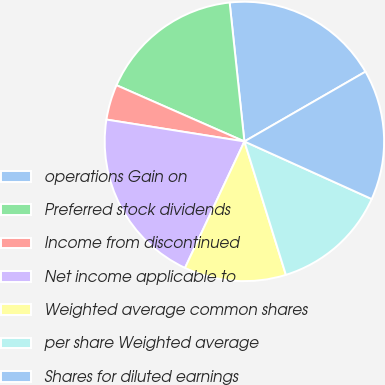Convert chart to OTSL. <chart><loc_0><loc_0><loc_500><loc_500><pie_chart><fcel>operations Gain on<fcel>Preferred stock dividends<fcel>Income from discontinued<fcel>Net income applicable to<fcel>Weighted average common shares<fcel>per share Weighted average<fcel>Shares for diluted earnings<nl><fcel>18.36%<fcel>16.72%<fcel>4.09%<fcel>20.51%<fcel>11.79%<fcel>13.44%<fcel>15.08%<nl></chart> 